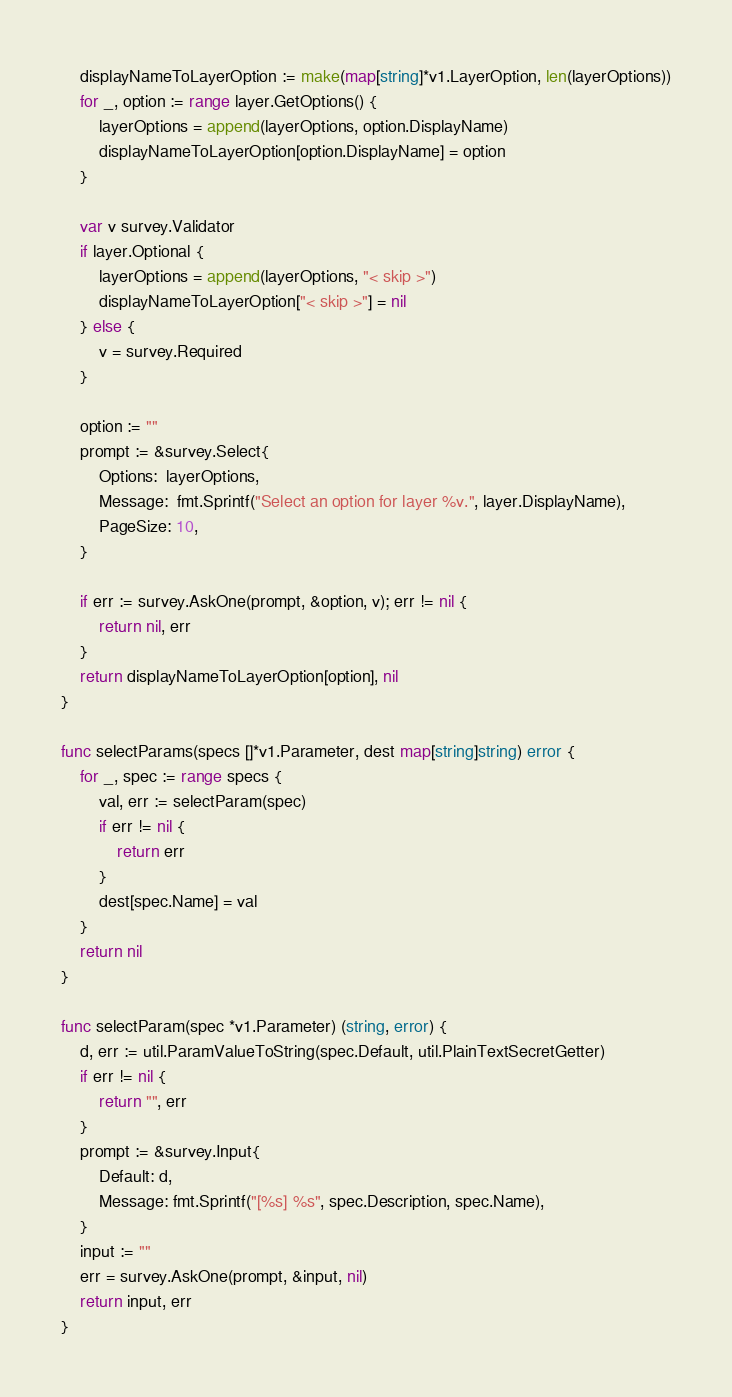<code> <loc_0><loc_0><loc_500><loc_500><_Go_>	displayNameToLayerOption := make(map[string]*v1.LayerOption, len(layerOptions))
	for _, option := range layer.GetOptions() {
		layerOptions = append(layerOptions, option.DisplayName)
		displayNameToLayerOption[option.DisplayName] = option
	}

	var v survey.Validator
	if layer.Optional {
		layerOptions = append(layerOptions, "< skip >")
		displayNameToLayerOption["< skip >"] = nil
	} else {
		v = survey.Required
	}

	option := ""
	prompt := &survey.Select{
		Options:  layerOptions,
		Message:  fmt.Sprintf("Select an option for layer %v.", layer.DisplayName),
		PageSize: 10,
	}

	if err := survey.AskOne(prompt, &option, v); err != nil {
		return nil, err
	}
	return displayNameToLayerOption[option], nil
}

func selectParams(specs []*v1.Parameter, dest map[string]string) error {
	for _, spec := range specs {
		val, err := selectParam(spec)
		if err != nil {
			return err
		}
		dest[spec.Name] = val
	}
	return nil
}

func selectParam(spec *v1.Parameter) (string, error) {
	d, err := util.ParamValueToString(spec.Default, util.PlainTextSecretGetter)
	if err != nil {
		return "", err
	}
	prompt := &survey.Input{
		Default: d,
		Message: fmt.Sprintf("[%s] %s", spec.Description, spec.Name),
	}
	input := ""
	err = survey.AskOne(prompt, &input, nil)
	return input, err
}
</code> 